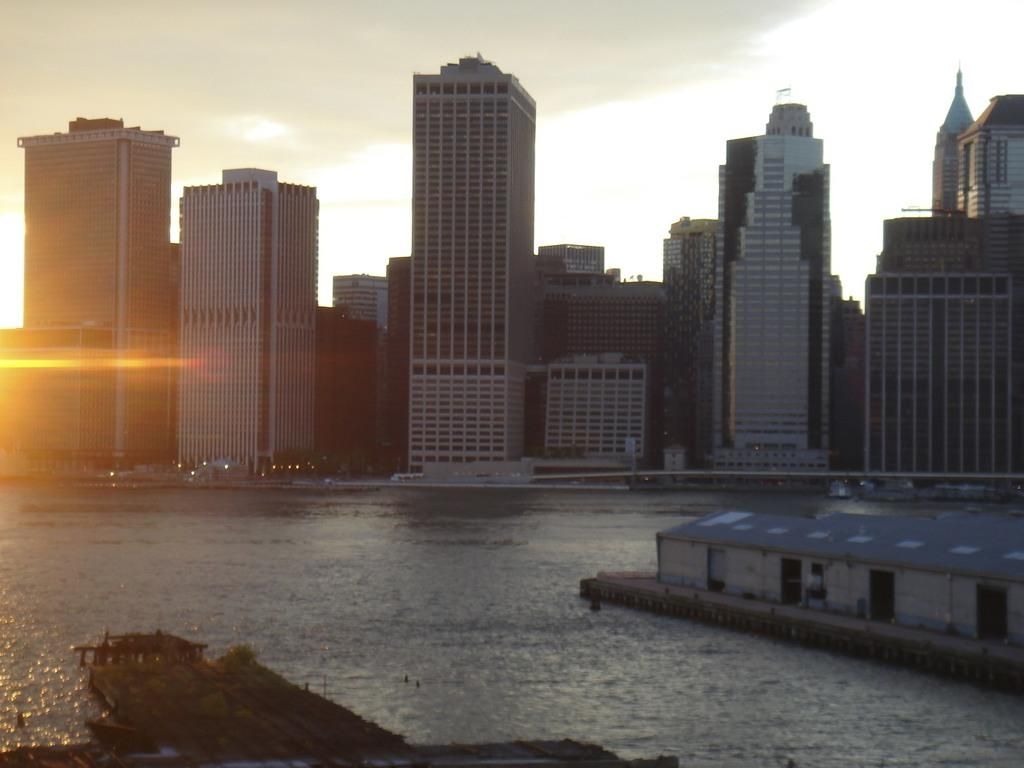What type of natural feature can be seen in the image? There is a river in the image. What kind of building is present in the image? There is a blue-colored warehouse in the image. Where is the warehouse located in the image? The warehouse is located in the right corner of the image. What type of urban landscape can be seen in the background of the image? There are skyscrapers visible in the background of the image. How does the warehouse express disgust in the image? The warehouse does not express any emotions, including disgust, in the image. 